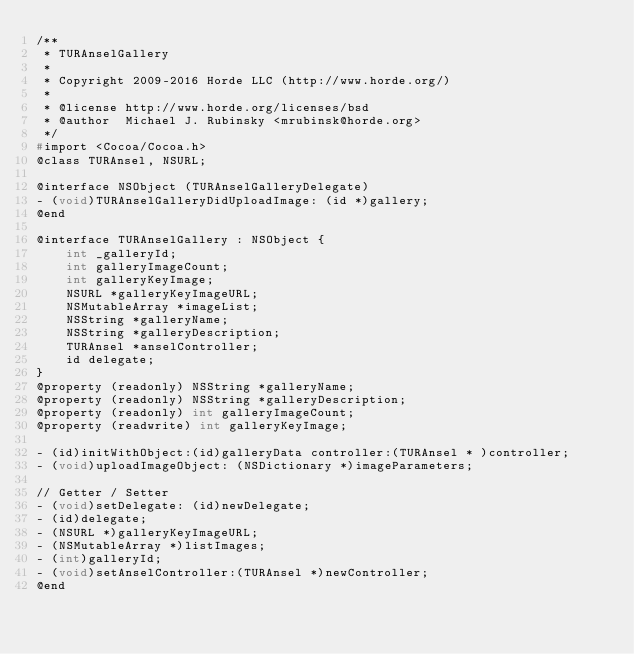Convert code to text. <code><loc_0><loc_0><loc_500><loc_500><_C_>/**
 * TURAnselGallery
 *
 * Copyright 2009-2016 Horde LLC (http://www.horde.org/)
 *
 * @license http://www.horde.org/licenses/bsd
 * @author  Michael J. Rubinsky <mrubinsk@horde.org>
 */
#import <Cocoa/Cocoa.h>
@class TURAnsel, NSURL;

@interface NSObject (TURAnselGalleryDelegate)
- (void)TURAnselGalleryDidUploadImage: (id *)gallery;
@end

@interface TURAnselGallery : NSObject {
    int _galleryId;
    int galleryImageCount;
    int galleryKeyImage;
    NSURL *galleryKeyImageURL;
    NSMutableArray *imageList;
    NSString *galleryName;
    NSString *galleryDescription;
    TURAnsel *anselController;
    id delegate;
}
@property (readonly) NSString *galleryName;
@property (readonly) NSString *galleryDescription;
@property (readonly) int galleryImageCount;
@property (readwrite) int galleryKeyImage;

- (id)initWithObject:(id)galleryData controller:(TURAnsel * )controller;
- (void)uploadImageObject: (NSDictionary *)imageParameters;

// Getter / Setter
- (void)setDelegate: (id)newDelegate;
- (id)delegate;
- (NSURL *)galleryKeyImageURL;
- (NSMutableArray *)listImages;
- (int)galleryId;
- (void)setAnselController:(TURAnsel *)newController;
@end</code> 